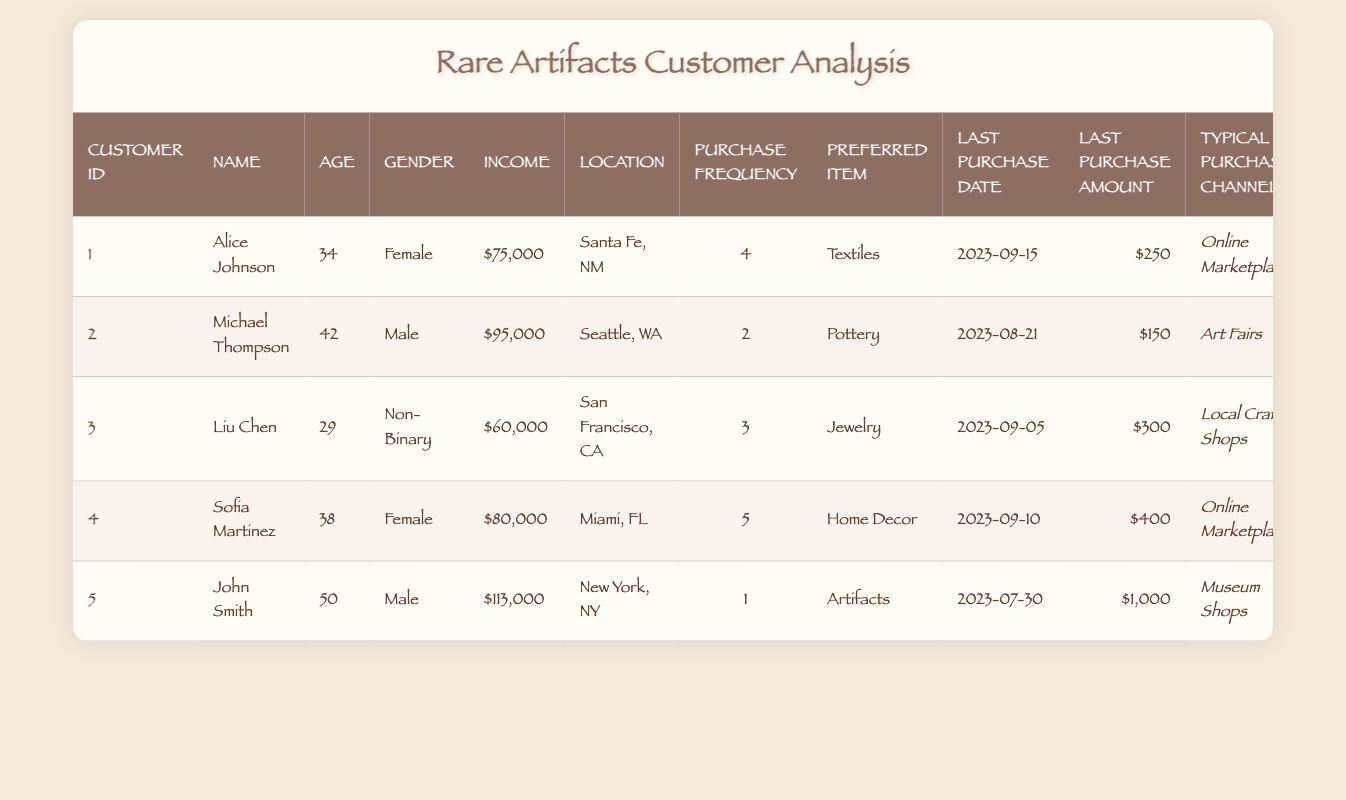What is the preferred item type of the customer with the highest income? The customer with the highest income is John Smith, who has an income of $113,000. Referring to the table, we can see that his preferred item type is "Artifacts."
Answer: Artifacts How many cultural items did Sofia Martinez purchase? Sofia Martinez's purchase frequency is listed as 5 in the table, meaning she has purchased 5 cultural items.
Answer: 5 Who made their last purchase on September 10, 2023? Looking at the last purchase date column, the customer who made their last purchase on September 10, 2023, is Sofia Martinez.
Answer: Sofia Martinez What is the average income of the customers listed in the table? The total income is calculated by adding the incomes: 75,000 + 95,000 + 60,000 + 80,000 + 113,000 = 423,000. There are 5 customers, so the average income is 423,000 / 5 = 84,600.
Answer: 84,600 Do any customers prefer "Jewelry" as their item type? Liu Chen is the customer who prefers "Jewelry" according to the table. Therefore, the answer is yes.
Answer: Yes Which purchase channel was used by the customer with a purchase frequency of 3? Liu Chen is the customer with a purchase frequency of 3. According to the table, his typical purchase channel is "Local Craft Shops."
Answer: Local Craft Shops What was the last purchase amount for Michael Thompson? From the last purchase amount column, Michael Thompson's last purchase amount is $150.
Answer: 150 How many customers have a purchasing frequency greater than 2? There are three customers with a purchasing frequency greater than 2: Alice Johnson (4), Sofia Martinez (5), and Liu Chen (3). So, the total count is 3.
Answer: 3 Is the last purchase amount for John Smith greater than $500? John Smith's last purchase amount is $1,000. Since $1,000 is greater than $500, the answer is yes.
Answer: Yes 